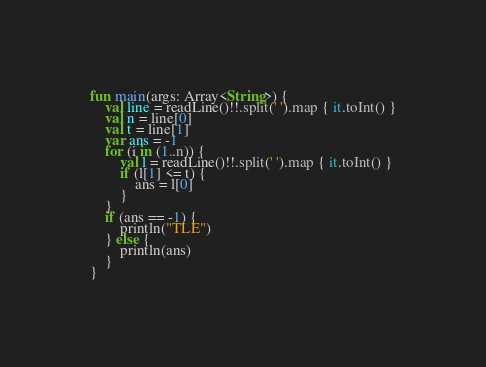<code> <loc_0><loc_0><loc_500><loc_500><_Kotlin_>fun main(args: Array<String>) {
    val line = readLine()!!.split(' ').map { it.toInt() }
    val n = line[0]
    val t = line[1]
    var ans = -1
    for (i in (1..n)) {
        val l = readLine()!!.split(' ').map { it.toInt() }
        if (l[1] <= t) {
            ans = l[0]
        }
    }
    if (ans == -1) {
        println("TLE")
    } else {
        println(ans)
    }
}</code> 